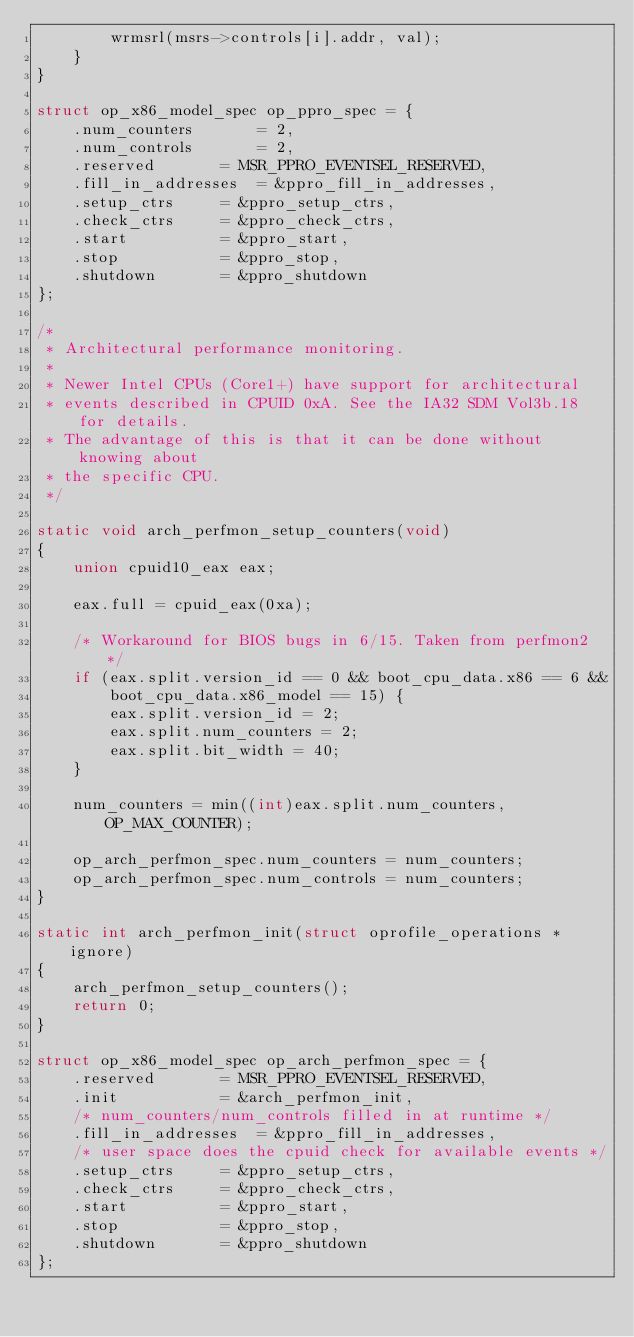<code> <loc_0><loc_0><loc_500><loc_500><_C_>		wrmsrl(msrs->controls[i].addr, val);
	}
}

struct op_x86_model_spec op_ppro_spec = {
	.num_counters		= 2,
	.num_controls		= 2,
	.reserved		= MSR_PPRO_EVENTSEL_RESERVED,
	.fill_in_addresses	= &ppro_fill_in_addresses,
	.setup_ctrs		= &ppro_setup_ctrs,
	.check_ctrs		= &ppro_check_ctrs,
	.start			= &ppro_start,
	.stop			= &ppro_stop,
	.shutdown		= &ppro_shutdown
};

/*
 * Architectural performance monitoring.
 *
 * Newer Intel CPUs (Core1+) have support for architectural
 * events described in CPUID 0xA. See the IA32 SDM Vol3b.18 for details.
 * The advantage of this is that it can be done without knowing about
 * the specific CPU.
 */

static void arch_perfmon_setup_counters(void)
{
	union cpuid10_eax eax;

	eax.full = cpuid_eax(0xa);

	/* Workaround for BIOS bugs in 6/15. Taken from perfmon2 */
	if (eax.split.version_id == 0 && boot_cpu_data.x86 == 6 &&
	    boot_cpu_data.x86_model == 15) {
		eax.split.version_id = 2;
		eax.split.num_counters = 2;
		eax.split.bit_width = 40;
	}

	num_counters = min((int)eax.split.num_counters, OP_MAX_COUNTER);

	op_arch_perfmon_spec.num_counters = num_counters;
	op_arch_perfmon_spec.num_controls = num_counters;
}

static int arch_perfmon_init(struct oprofile_operations *ignore)
{
	arch_perfmon_setup_counters();
	return 0;
}

struct op_x86_model_spec op_arch_perfmon_spec = {
	.reserved		= MSR_PPRO_EVENTSEL_RESERVED,
	.init			= &arch_perfmon_init,
	/* num_counters/num_controls filled in at runtime */
	.fill_in_addresses	= &ppro_fill_in_addresses,
	/* user space does the cpuid check for available events */
	.setup_ctrs		= &ppro_setup_ctrs,
	.check_ctrs		= &ppro_check_ctrs,
	.start			= &ppro_start,
	.stop			= &ppro_stop,
	.shutdown		= &ppro_shutdown
};
</code> 